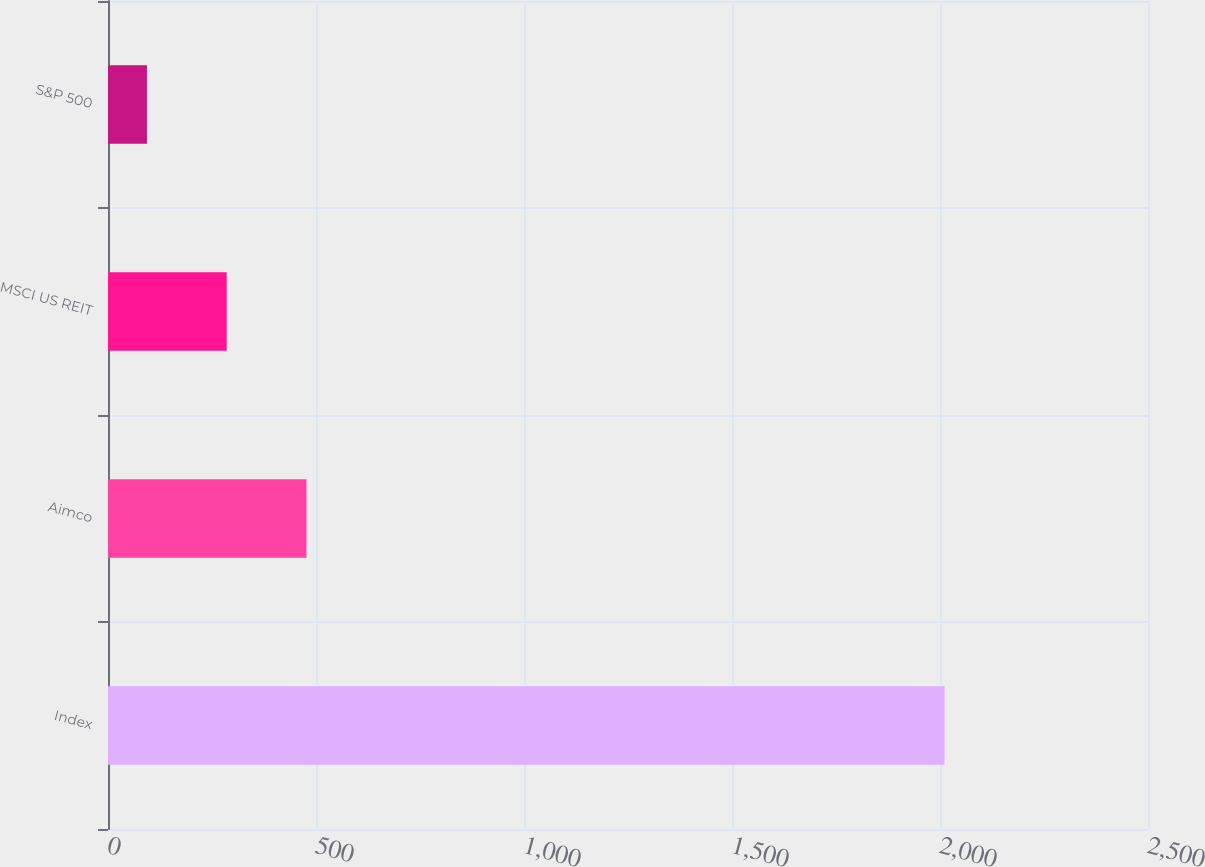Convert chart to OTSL. <chart><loc_0><loc_0><loc_500><loc_500><bar_chart><fcel>Index<fcel>Aimco<fcel>MSCI US REIT<fcel>S&P 500<nl><fcel>2011<fcel>477.09<fcel>285.35<fcel>93.61<nl></chart> 